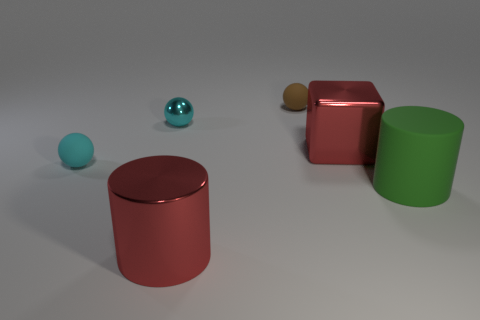There is a tiny cyan object in front of the small metal ball; is it the same shape as the green object?
Keep it short and to the point. No. The metal object that is the same color as the shiny block is what size?
Your answer should be very brief. Large. What number of red things are big shiny cylinders or big cylinders?
Your response must be concise. 1. How many other things are there of the same shape as the tiny cyan metal thing?
Provide a short and direct response. 2. The object that is both on the right side of the small brown matte ball and to the left of the green object has what shape?
Keep it short and to the point. Cube. There is a small cyan rubber thing; are there any things behind it?
Offer a very short reply. Yes. There is a cyan metal object that is the same shape as the tiny cyan rubber object; what size is it?
Give a very brief answer. Small. Is the small metal thing the same shape as the brown object?
Offer a terse response. Yes. There is a cyan thing that is right of the rubber sphere to the left of the tiny brown thing; what is its size?
Give a very brief answer. Small. The other small metal thing that is the same shape as the tiny brown thing is what color?
Ensure brevity in your answer.  Cyan. 